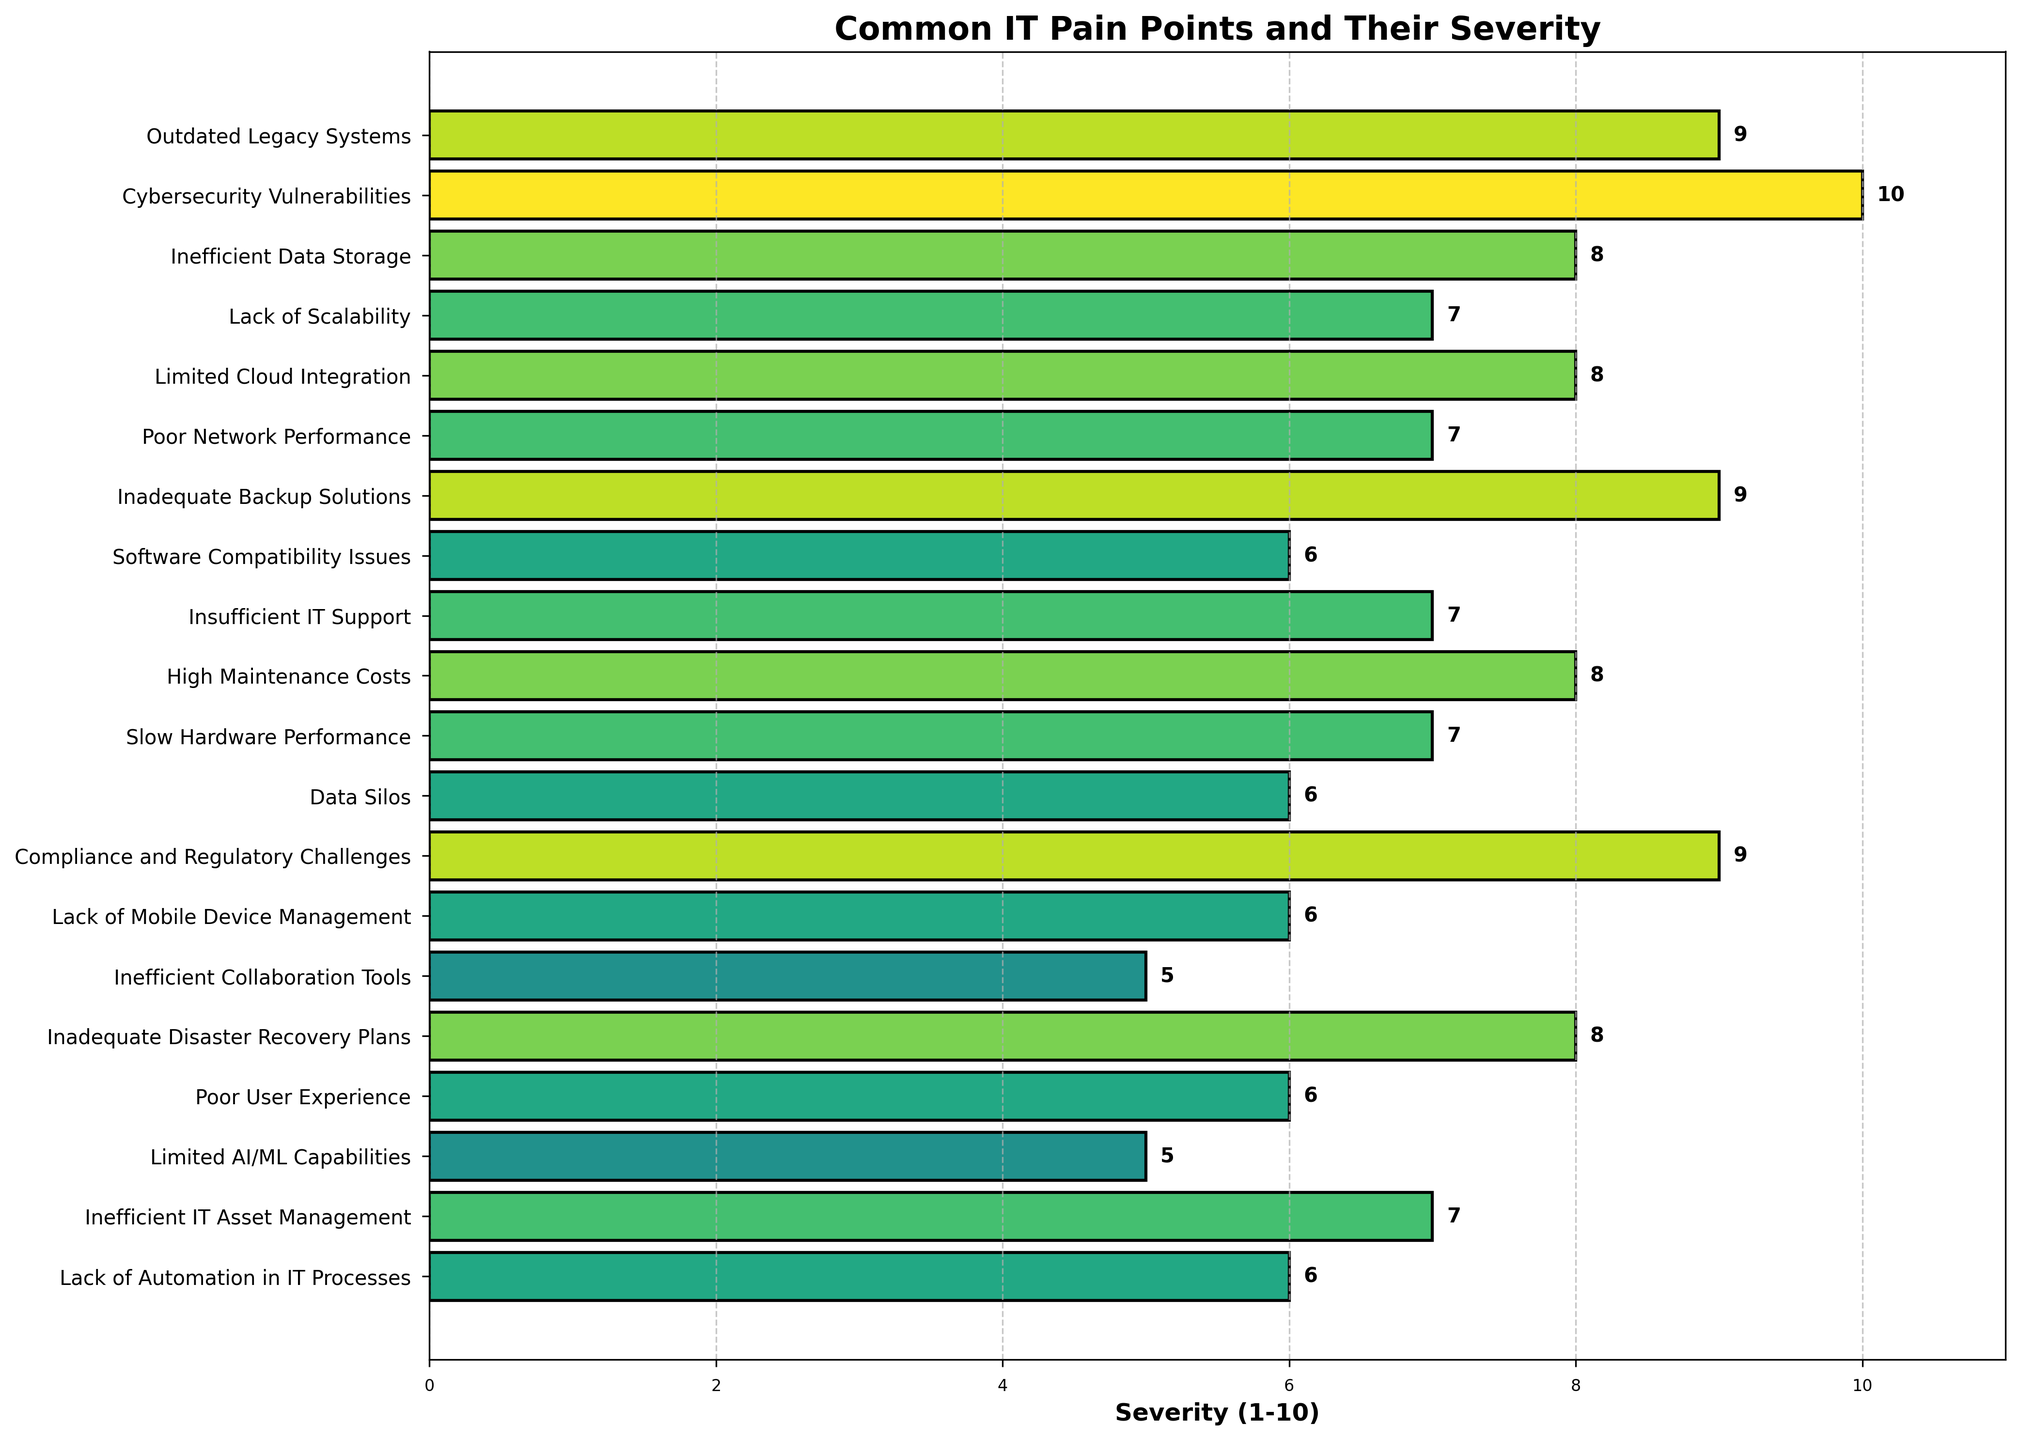What's the most severe IT pain point faced by organizations? The figure shows different IT pain points along with their severity rankings. The one with the highest severity (10) indicates the most severe issue, which is Cybersecurity Vulnerabilities.
Answer: Cybersecurity Vulnerabilities How many pain points have a severity of 8 or higher? To determine this, count the entries in the figure with severity values 8, 9, or 10. There are six such entries: Outdated Legacy Systems (9), Cybersecurity Vulnerabilities (10), Inefficient Data Storage (8), Inadequate Backup Solutions (9), High Maintenance Costs (8), and Compliance and Regulatory Challenges (9).
Answer: 6 Which pain point has the lowest severity? The figure arranges the pain points by their severity scores. The lowest severity score (5) is shared by Inefficient Collaboration Tools and Limited AI/ML Capabilities.
Answer: Inefficient Collaboration Tools and Limited AI/ML Capabilities How does the severity of Poor Network Performance compare to Inefficient IT Asset Management? Find both pain points on the figure and compare their severity scores. Both Poor Network Performance and Inefficient IT Asset Management have a severity score of 7.
Answer: Equal What is the average severity score for the pain points listed? Add all the severity scores together and divide by the number of pain points. The total severity scores are 9 + 10 + 8 + 7 + 8 + 7 + 9 + 6 + 7 + 8 + 7 + 6 + 9 + 6 + 5 + 8 + 6 + 5 + 7 + 6 = 140, with 20 pain points. Thus, the average is 140 / 20 = 7.
Answer: 7 Between Outdated Legacy Systems and Limited Cloud Integration, which one has a higher severity? Compare the severity scores of both pain points in the figure. Outdated Legacy Systems has a severity of 9, while Limited Cloud Integration has a severity of 8.
Answer: Outdated Legacy Systems How does the color intensity of the bar for Cybersecurity Vulnerabilities compare to other pain points? The color intensity of the bar for Cybersecurity Vulnerabilities is the darkest, as it represents the highest severity score of 10. Other bars will have lighter colors based on their lower severity scores.
Answer: Darkest What is the combined severity score of Lack of Scalability and Software Compatibility Issues? Find the severity scores of both pain points and add them up. Lack of Scalability has a severity of 7, and Software Compatibility Issues has a severity of 6. The combined score is 7 + 6 = 13.
Answer: 13 Identify a pain point with a severity score of 7 that affects user performance. From the list of pain points with a severity of 7, identify one related to user performance. Poor Network Performance and Slow Hardware Performance both have a severity of 7, and both affect user performance.
Answer: Poor Network Performance or Slow Hardware Performance 